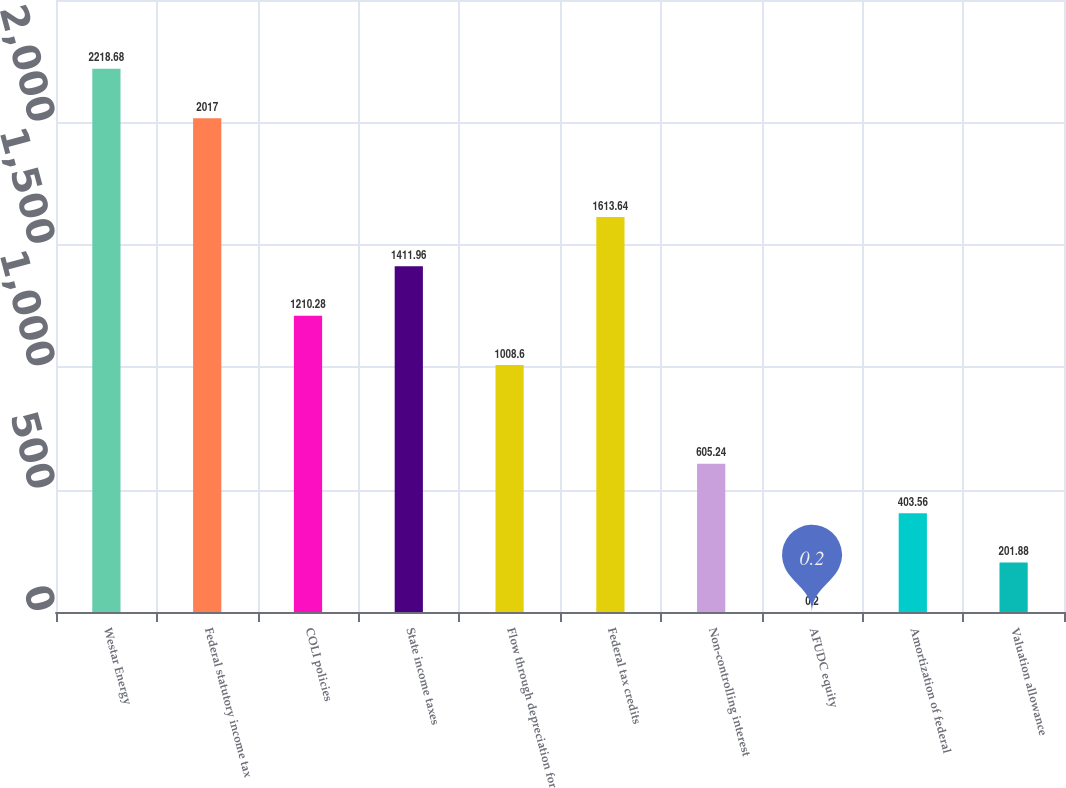Convert chart. <chart><loc_0><loc_0><loc_500><loc_500><bar_chart><fcel>Westar Energy<fcel>Federal statutory income tax<fcel>COLI policies<fcel>State income taxes<fcel>Flow through depreciation for<fcel>Federal tax credits<fcel>Non-controlling interest<fcel>AFUDC equity<fcel>Amortization of federal<fcel>Valuation allowance<nl><fcel>2218.68<fcel>2017<fcel>1210.28<fcel>1411.96<fcel>1008.6<fcel>1613.64<fcel>605.24<fcel>0.2<fcel>403.56<fcel>201.88<nl></chart> 